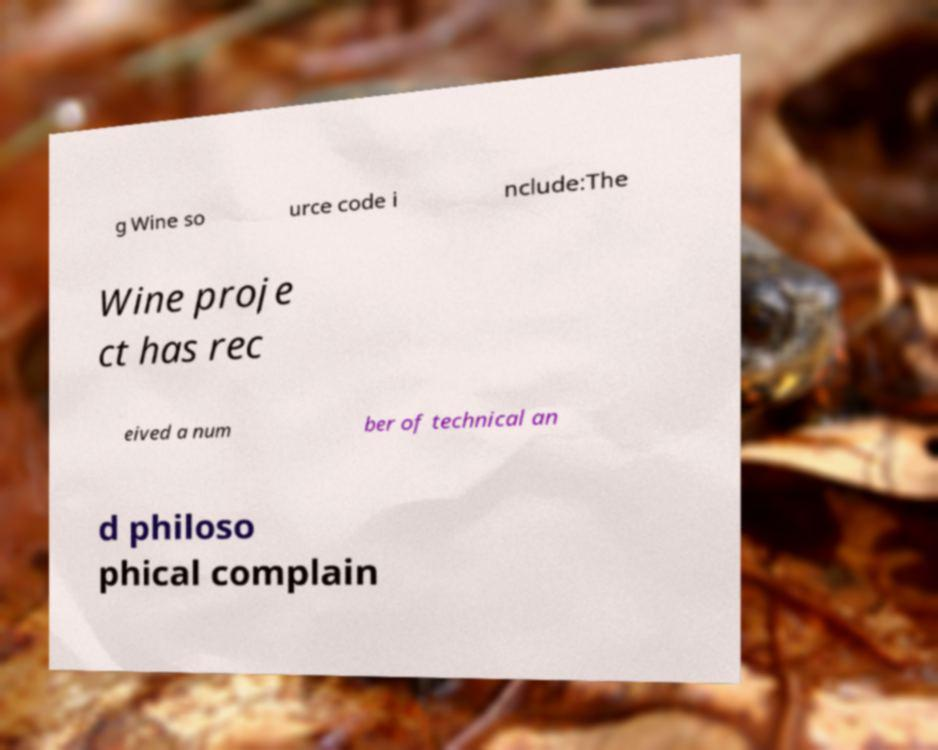Could you assist in decoding the text presented in this image and type it out clearly? g Wine so urce code i nclude:The Wine proje ct has rec eived a num ber of technical an d philoso phical complain 